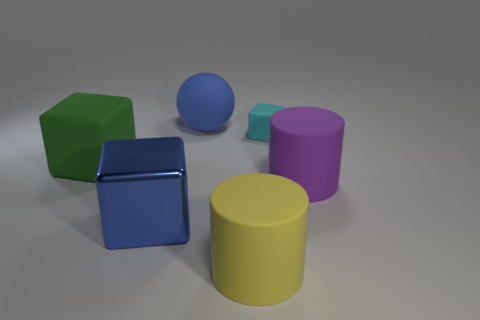Are there any patterns or symmetry in the way objects are arranged? The objects do not seem to exhibit an intentional pattern or symmetry. Their distribution appears somewhat random, with different shapes and colors scattered across the surface without a discernable systematic arrangement. 